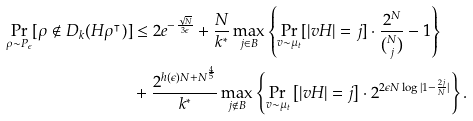Convert formula to latex. <formula><loc_0><loc_0><loc_500><loc_500>\Pr _ { \rho \sim P _ { \epsilon } } [ \rho \notin D _ { k } ( H \rho ^ { \intercal } ) ] & \leq 2 e ^ { - \frac { \sqrt { N } } { 3 \epsilon } } + \frac { N } { k ^ { * } } \max _ { j \in B } \left \{ \Pr _ { v \sim \mu _ { t } } [ | v H | = j ] \cdot \frac { 2 ^ { N } } { \binom { N } { j } } - 1 \right \} \\ & + \frac { 2 ^ { h ( \epsilon ) N + N ^ { \frac { 4 } { 5 } } } } { k ^ { * } } \max _ { j \notin B } \left \{ \Pr _ { v \sim \mu _ { t } } \left [ | v H | = j \right ] \cdot 2 ^ { 2 \epsilon N \log | 1 - \frac { 2 j } { N } | } \right \} .</formula> 